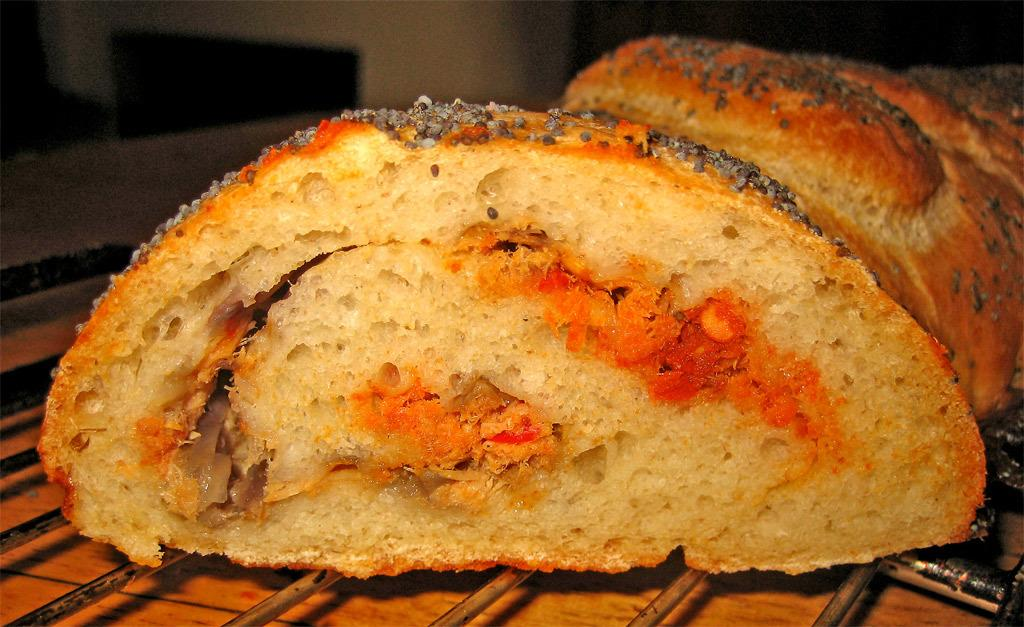What is being cooked or prepared in the image? There are snacks on a grill in the image. Where is the hen located in the image? There is no hen present in the image. What type of arch can be seen in the image? There is no arch present in the image. 